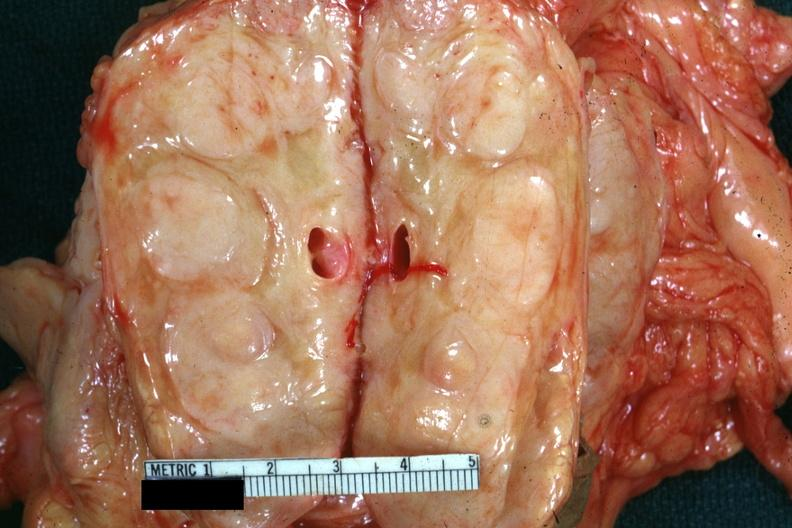what was example diagnosed as cell sarcoma?
Answer the question using a single word or phrase. Diagnosed reticulum 